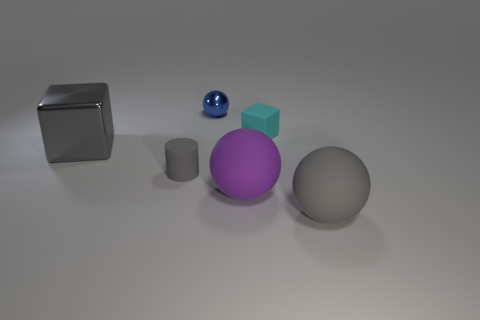Is there any other thing that is made of the same material as the big gray block?
Keep it short and to the point. Yes. There is a large ball that is the same color as the small matte cylinder; what material is it?
Give a very brief answer. Rubber. The rubber cube has what color?
Provide a short and direct response. Cyan. Are there more big gray cubes that are to the left of the small rubber cube than large purple objects that are to the right of the purple rubber ball?
Offer a terse response. Yes. There is a big object to the left of the small sphere; what color is it?
Keep it short and to the point. Gray. There is a gray rubber object to the right of the purple sphere; is it the same size as the cube that is behind the metallic cube?
Provide a short and direct response. No. What number of things are either shiny balls or big rubber cylinders?
Your answer should be very brief. 1. What material is the large ball behind the big gray object that is on the right side of the small blue metal object?
Offer a very short reply. Rubber. What number of other large matte things are the same shape as the large purple thing?
Ensure brevity in your answer.  1. Are there any large metal things of the same color as the tiny cylinder?
Make the answer very short. Yes. 